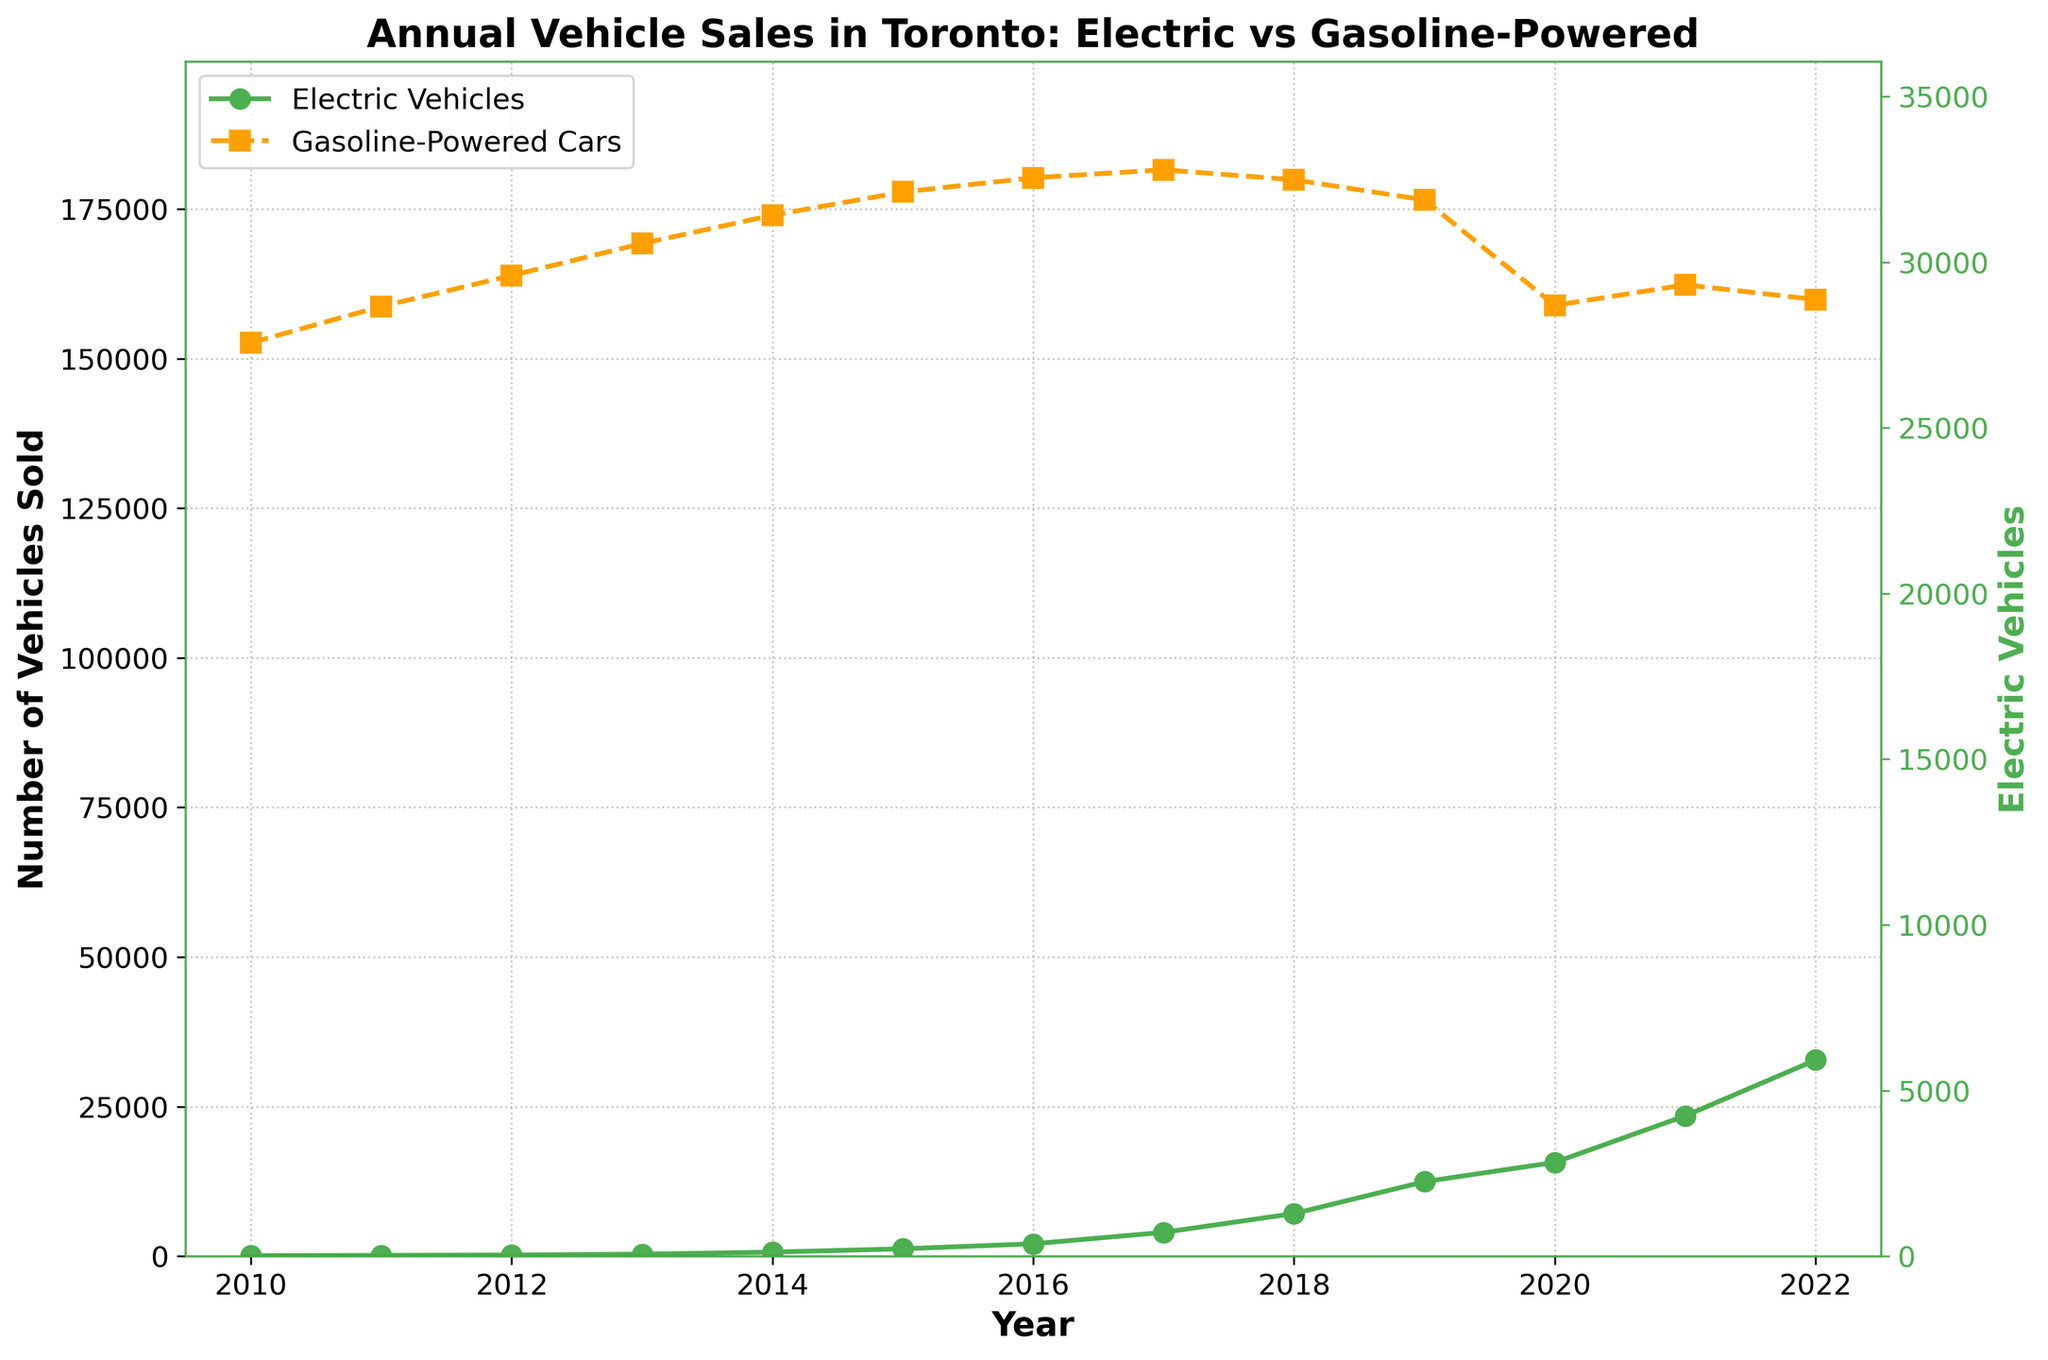Which year saw the highest sales of electric vehicles? Look at the line for electric vehicle sales, and identify the year with the highest peak, which occurs at the point with the highest y-value.
Answer: 2022 How do the sales trends for electric vehicles and gasoline-powered cars compare between 2015 and 2020? Observe the trend lines for both electric vehicles and gasoline-powered cars from 2015 to 2020. EV sales show a sharp increasing trend, while gasoline-powered cars show a slight decline in sales.
Answer: EVs increased, Gasoline declined What was the approximate increase in electric vehicle sales from 2013 to 2014? Subtract the 2013 sales of electric vehicles from the 2014 sales: 682 (2014) - 345 (2013) = 337.
Answer: 337 vehicles In which year did electric vehicle sales first surpass 10,000 units? Identify the year when the electric vehicle sales line first crosses the 10,000-unit mark. This occurs in 2019.
Answer: 2019 By how much did gasoline-powered car sales decrease from 2016 to 2020? Subtract the 2020 sales of gasoline-powered cars from the 2016 sales: 180234 (2016) - 158901 (2020) = 21333.
Answer: 21333 cars What is the color representation for electric vehicles and gasoline-powered cars in the chart? Look at the color of the lines and their corresponding labels in the legend. Electric vehicles are represented by the green line, and gasoline-powered cars are represented by the orange line.
Answer: Green for EVs, Orange for Gasoline Cars Which year experienced the steepest growth in electric vehicle sales? Look for the year with the steepest upward slope in the electric vehicle sales line. The steepest increase occurs between 2017 and 2018.
Answer: Between 2017 and 2018 What were the sales of gasoline-powered cars in the year when electric vehicle sales reached approximately 3,2789? Identify the year when electric vehicle sales reached approximately 3,2789, which is 2022, and then look at the corresponding gasoline-powered car sales for that year.
Answer: 159876 cars Are electric vehicle sales consistently increasing throughout the period shown in the chart? Confirm if the line representing electric vehicle sales continuously rises year-over-year without any decreases. The line consistently increases from 2010 to 2022.
Answer: Yes Given the data, do gasoline-powered cars ever reverse the downward trend shown in recent years? Trace the line representing gasoline-powered cars and observe if it ever increases after showing a decline. Around 2021, sales slightly increase but then start decreasing again.
Answer: Briefly in 2021 